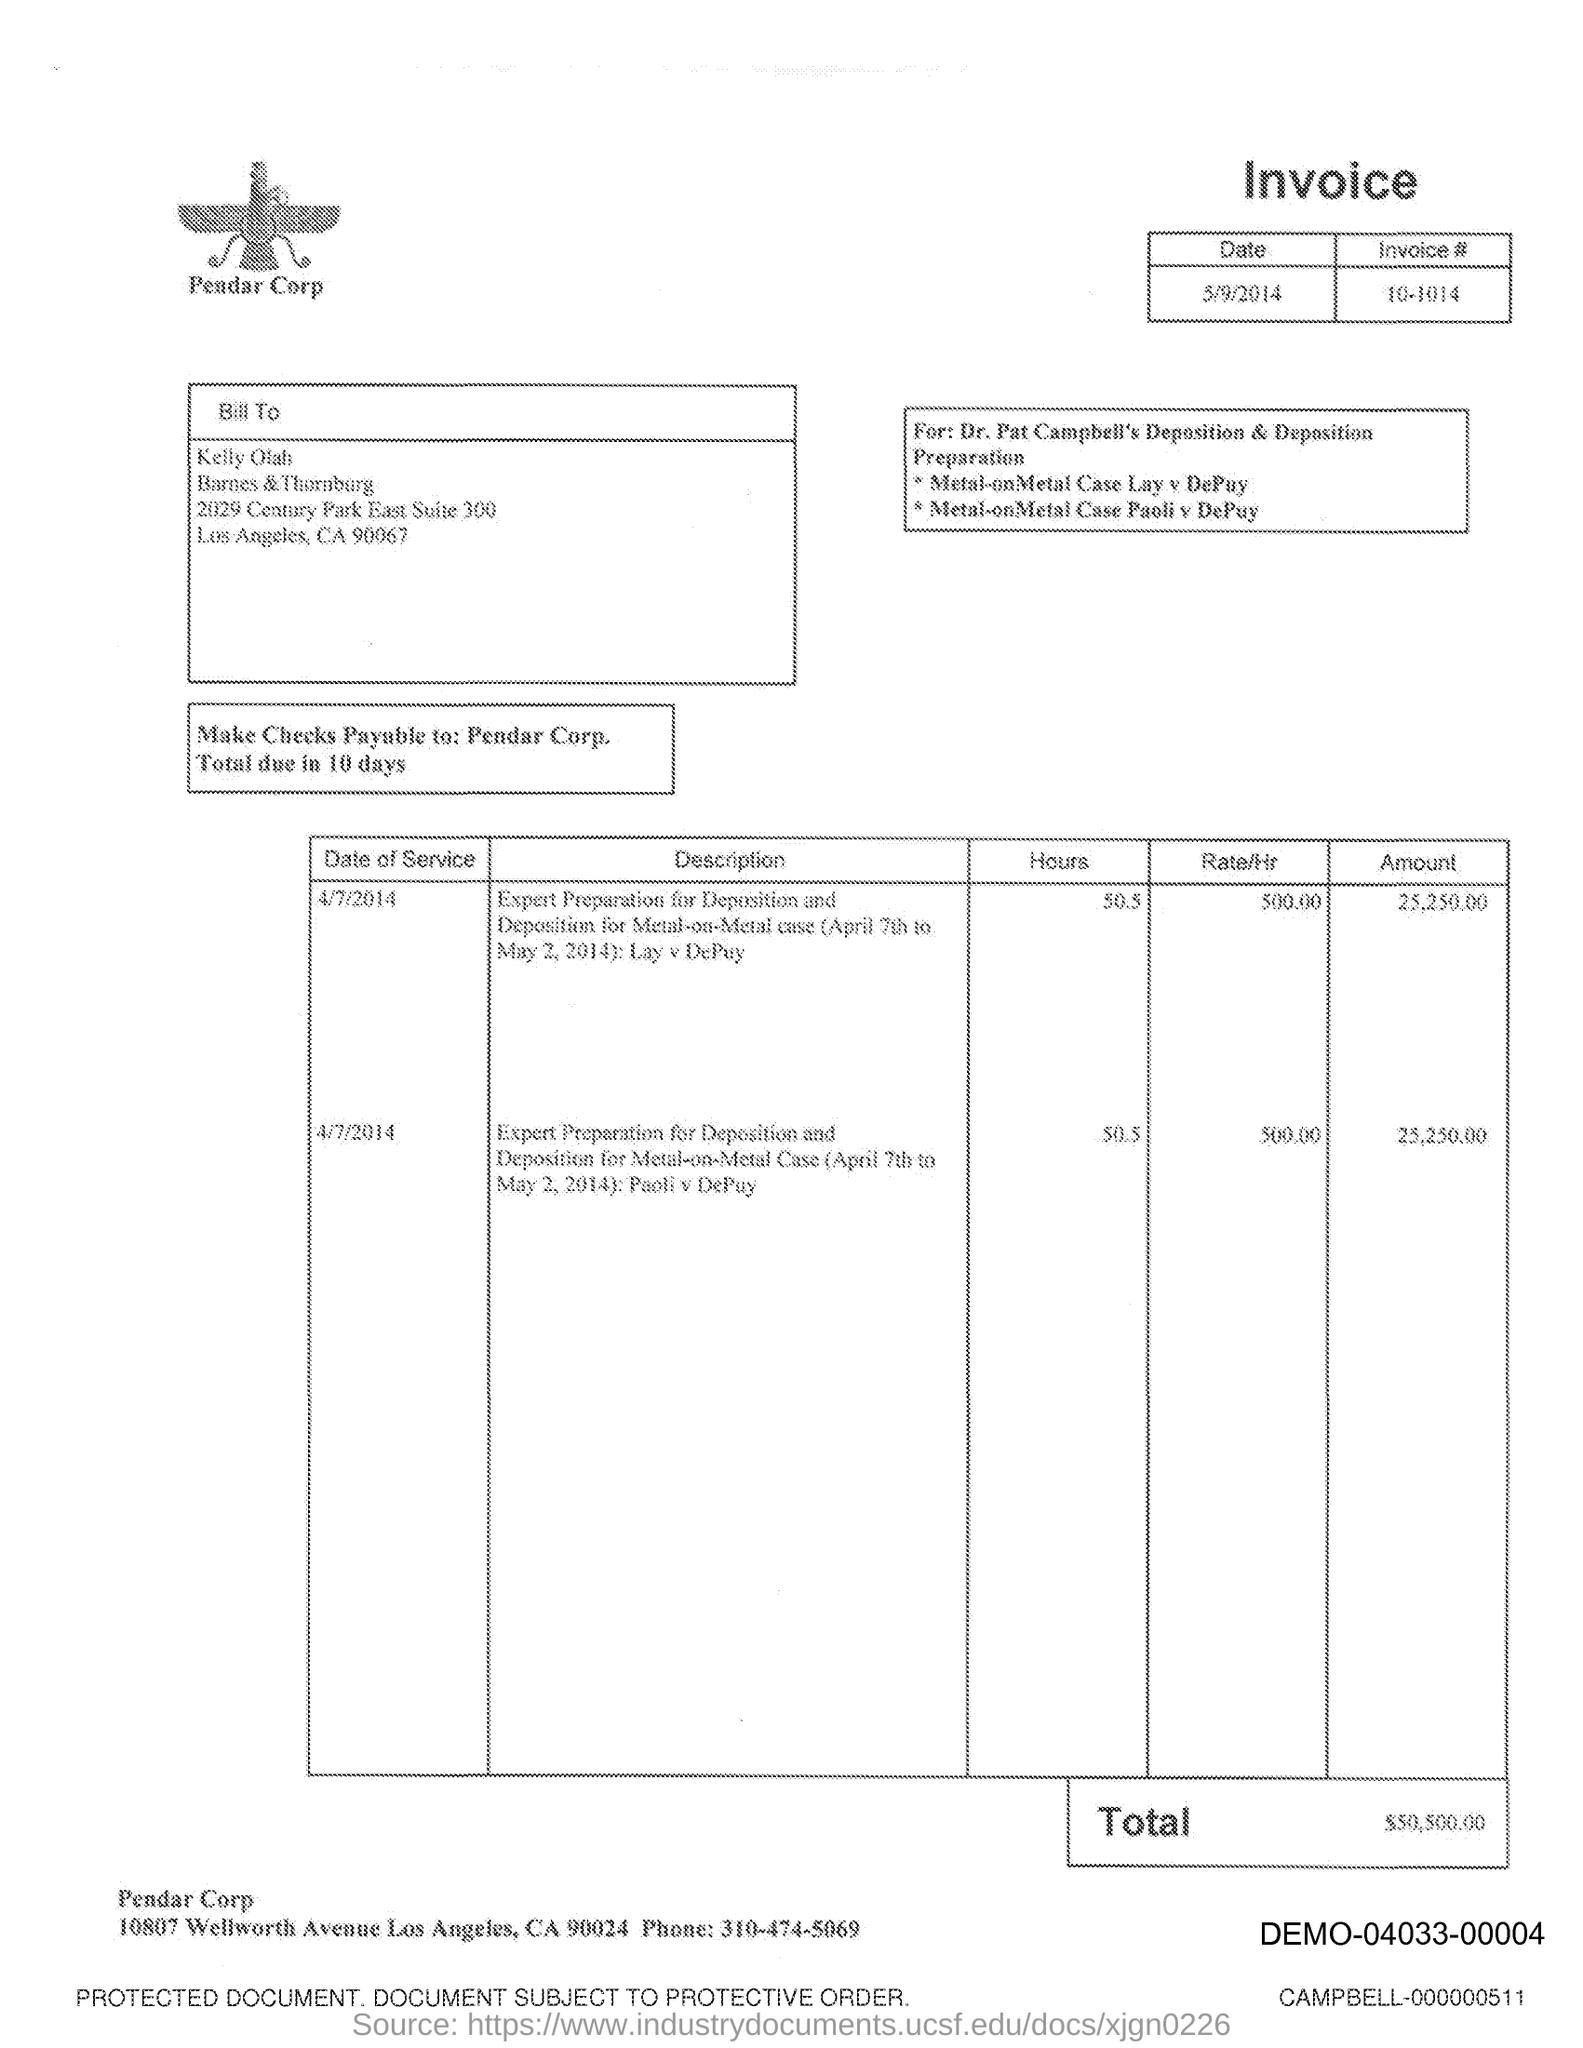What is the issued date of this invoice?
Ensure brevity in your answer.  5/9/2014. What is the invoice # given in the document?
Offer a terse response. 10-1014. What is the total amount of the invoice?
Your answer should be compact. $50,500.00. 